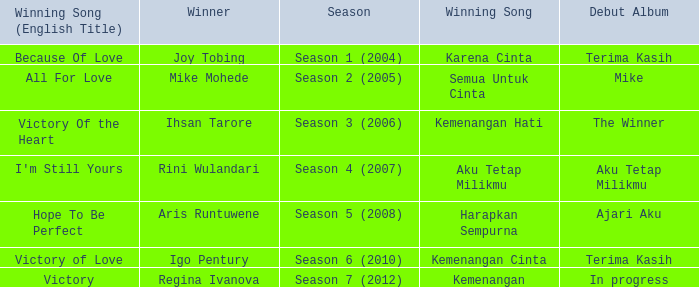Which English winning song had the winner aris runtuwene? Hope To Be Perfect. 